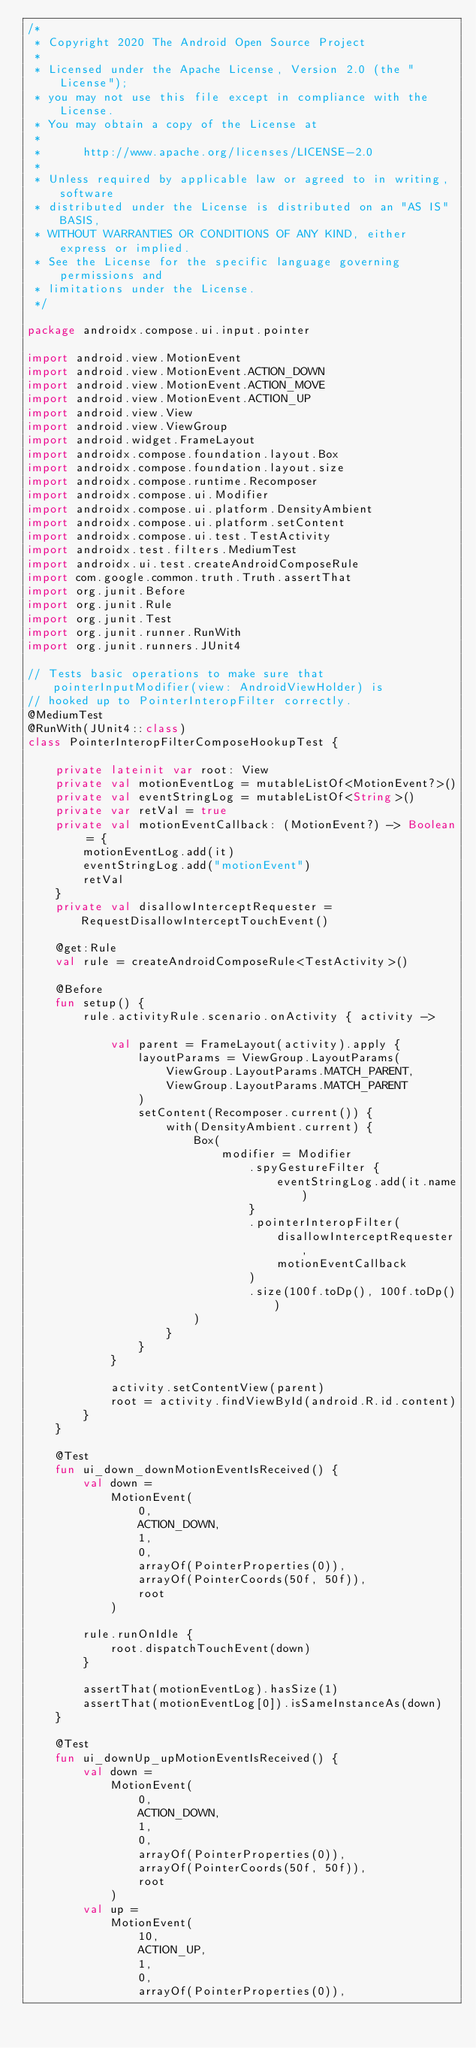<code> <loc_0><loc_0><loc_500><loc_500><_Kotlin_>/*
 * Copyright 2020 The Android Open Source Project
 *
 * Licensed under the Apache License, Version 2.0 (the "License");
 * you may not use this file except in compliance with the License.
 * You may obtain a copy of the License at
 *
 *      http://www.apache.org/licenses/LICENSE-2.0
 *
 * Unless required by applicable law or agreed to in writing, software
 * distributed under the License is distributed on an "AS IS" BASIS,
 * WITHOUT WARRANTIES OR CONDITIONS OF ANY KIND, either express or implied.
 * See the License for the specific language governing permissions and
 * limitations under the License.
 */

package androidx.compose.ui.input.pointer

import android.view.MotionEvent
import android.view.MotionEvent.ACTION_DOWN
import android.view.MotionEvent.ACTION_MOVE
import android.view.MotionEvent.ACTION_UP
import android.view.View
import android.view.ViewGroup
import android.widget.FrameLayout
import androidx.compose.foundation.layout.Box
import androidx.compose.foundation.layout.size
import androidx.compose.runtime.Recomposer
import androidx.compose.ui.Modifier
import androidx.compose.ui.platform.DensityAmbient
import androidx.compose.ui.platform.setContent
import androidx.compose.ui.test.TestActivity
import androidx.test.filters.MediumTest
import androidx.ui.test.createAndroidComposeRule
import com.google.common.truth.Truth.assertThat
import org.junit.Before
import org.junit.Rule
import org.junit.Test
import org.junit.runner.RunWith
import org.junit.runners.JUnit4

// Tests basic operations to make sure that pointerInputModifier(view: AndroidViewHolder) is
// hooked up to PointerInteropFilter correctly.
@MediumTest
@RunWith(JUnit4::class)
class PointerInteropFilterComposeHookupTest {

    private lateinit var root: View
    private val motionEventLog = mutableListOf<MotionEvent?>()
    private val eventStringLog = mutableListOf<String>()
    private var retVal = true
    private val motionEventCallback: (MotionEvent?) -> Boolean = {
        motionEventLog.add(it)
        eventStringLog.add("motionEvent")
        retVal
    }
    private val disallowInterceptRequester = RequestDisallowInterceptTouchEvent()

    @get:Rule
    val rule = createAndroidComposeRule<TestActivity>()

    @Before
    fun setup() {
        rule.activityRule.scenario.onActivity { activity ->

            val parent = FrameLayout(activity).apply {
                layoutParams = ViewGroup.LayoutParams(
                    ViewGroup.LayoutParams.MATCH_PARENT,
                    ViewGroup.LayoutParams.MATCH_PARENT
                )
                setContent(Recomposer.current()) {
                    with(DensityAmbient.current) {
                        Box(
                            modifier = Modifier
                                .spyGestureFilter {
                                    eventStringLog.add(it.name)
                                }
                                .pointerInteropFilter(
                                    disallowInterceptRequester,
                                    motionEventCallback
                                )
                                .size(100f.toDp(), 100f.toDp())
                        )
                    }
                }
            }

            activity.setContentView(parent)
            root = activity.findViewById(android.R.id.content)
        }
    }

    @Test
    fun ui_down_downMotionEventIsReceived() {
        val down =
            MotionEvent(
                0,
                ACTION_DOWN,
                1,
                0,
                arrayOf(PointerProperties(0)),
                arrayOf(PointerCoords(50f, 50f)),
                root
            )

        rule.runOnIdle {
            root.dispatchTouchEvent(down)
        }

        assertThat(motionEventLog).hasSize(1)
        assertThat(motionEventLog[0]).isSameInstanceAs(down)
    }

    @Test
    fun ui_downUp_upMotionEventIsReceived() {
        val down =
            MotionEvent(
                0,
                ACTION_DOWN,
                1,
                0,
                arrayOf(PointerProperties(0)),
                arrayOf(PointerCoords(50f, 50f)),
                root
            )
        val up =
            MotionEvent(
                10,
                ACTION_UP,
                1,
                0,
                arrayOf(PointerProperties(0)),</code> 